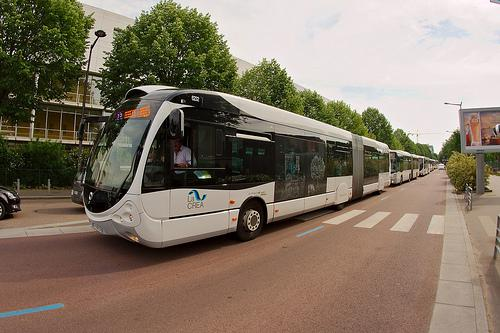Question: what color are the buses?
Choices:
A. Yellow.
B. White.
C. Grey.
D. Blue.
Answer with the letter. Answer: B Question: why is it so bright?
Choices:
A. Bright lights.
B. Reflecting light.
C. It's yellow.
D. Sunny.
Answer with the letter. Answer: D Question: where are the buses?
Choices:
A. The street.
B. The depot.
C. In the grass.
D. At McDonald's.
Answer with the letter. Answer: A Question: what color are the bus windows?
Choices:
A. Brown.
B. Blue.
C. Tan.
D. Black.
Answer with the letter. Answer: D Question: when is the photo taken?
Choices:
A. Night.
B. Day time.
C. April.
D. Winter.
Answer with the letter. Answer: B 